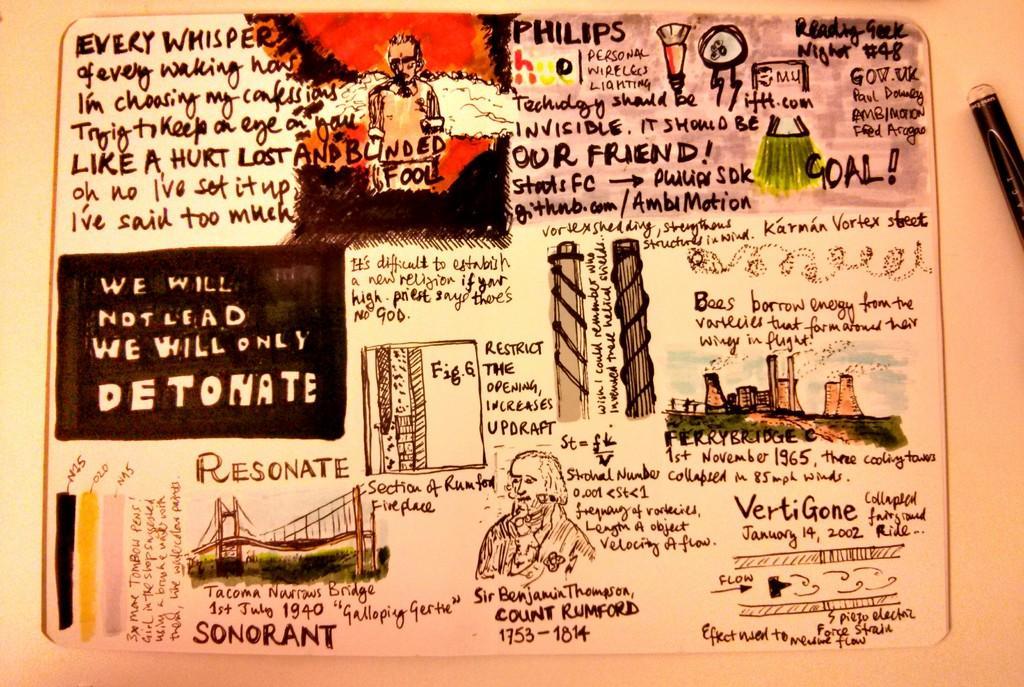Can you describe this image briefly? In this image I can see the sketch of few buildings, a bridge and few persons and I can see something written in the image. 